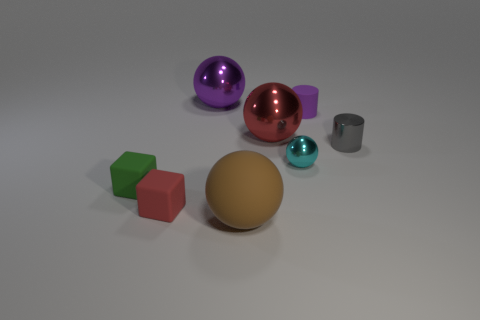Is the color of the tiny rubber cylinder the same as the big ball left of the large brown ball?
Your answer should be compact. Yes. There is a matte object to the left of the red thing on the left side of the large thing that is in front of the big red ball; what shape is it?
Offer a terse response. Cube. Are there more small cylinders that are to the right of the tiny red object than large purple metallic balls?
Offer a terse response. Yes. There is a tiny red matte thing; does it have the same shape as the green object left of the purple cylinder?
Your answer should be very brief. Yes. What shape is the big metallic object that is the same color as the rubber cylinder?
Your answer should be compact. Sphere. There is a purple matte object behind the big object that is on the right side of the brown object; what number of metallic things are in front of it?
Make the answer very short. 3. The shiny object that is the same size as the red ball is what color?
Ensure brevity in your answer.  Purple. What is the size of the red thing behind the small block that is behind the small red matte block?
Keep it short and to the point. Large. What number of other objects are there of the same size as the matte cylinder?
Offer a very short reply. 4. What number of tiny green things are there?
Make the answer very short. 1. 